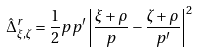Convert formula to latex. <formula><loc_0><loc_0><loc_500><loc_500>\hat { \Delta } ^ { r } _ { \xi , \zeta } = \frac { 1 } { 2 } p p ^ { \prime } \left | \frac { \xi + \rho } { p } - \frac { \zeta + \rho } { p ^ { \prime } } \right | ^ { 2 }</formula> 